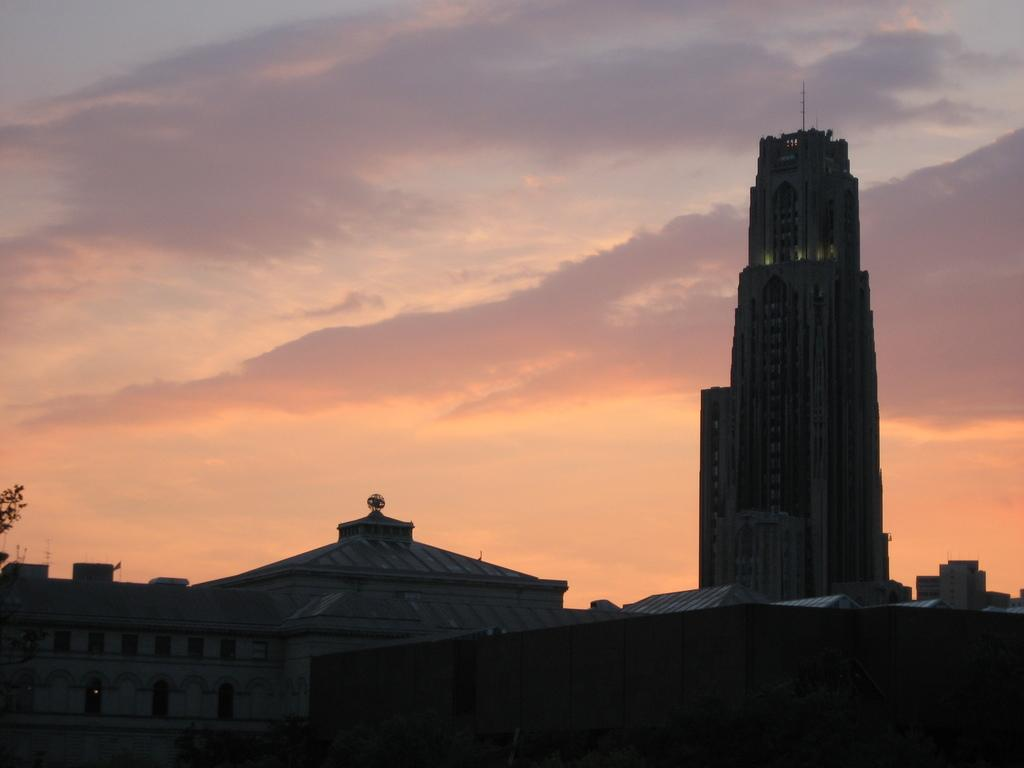What type of structures can be seen in the image? There are houses in the image. What can be found on the left side of the image? There are leaves on the left side of the image. What is visible in the background of the image? The sky is visible in the image. What is present in the sky? Clouds are present in the sky. What type of event is being reported in the image? There is no event being reported in the image; it simply shows houses, leaves, sky, and clouds. What news can be found in the image? There is no news present in the image; it is a visual representation of houses, leaves, sky, and clouds. 